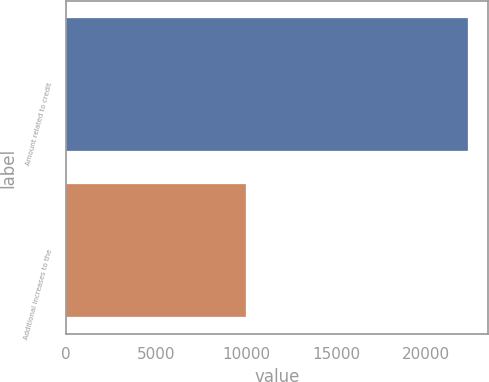<chart> <loc_0><loc_0><loc_500><loc_500><bar_chart><fcel>Amount related to credit<fcel>Additional increases to the<nl><fcel>22306<fcel>9994<nl></chart> 